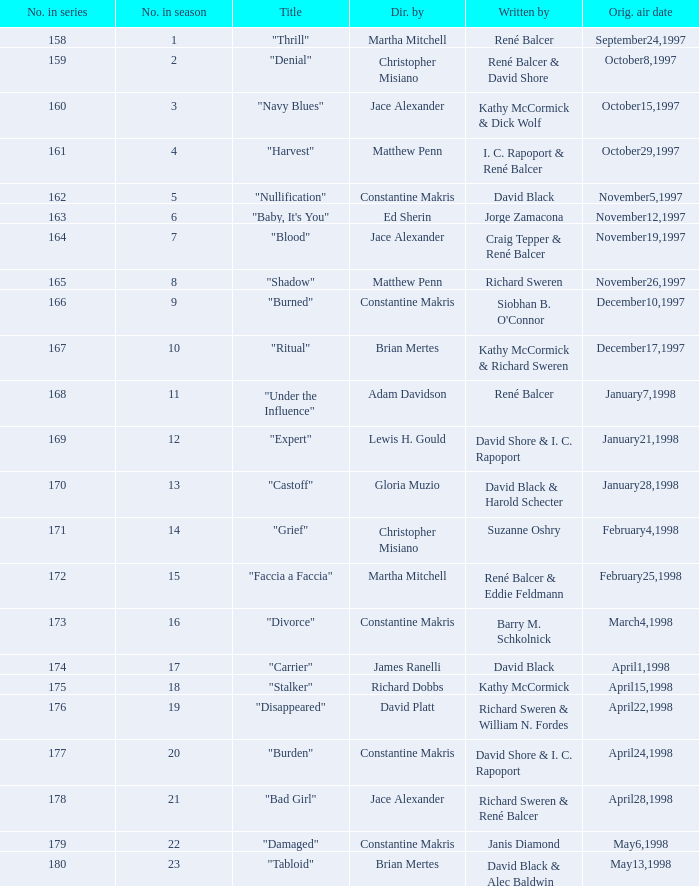Identify the episode title directed by ed sheeran. "Baby, It's You". 